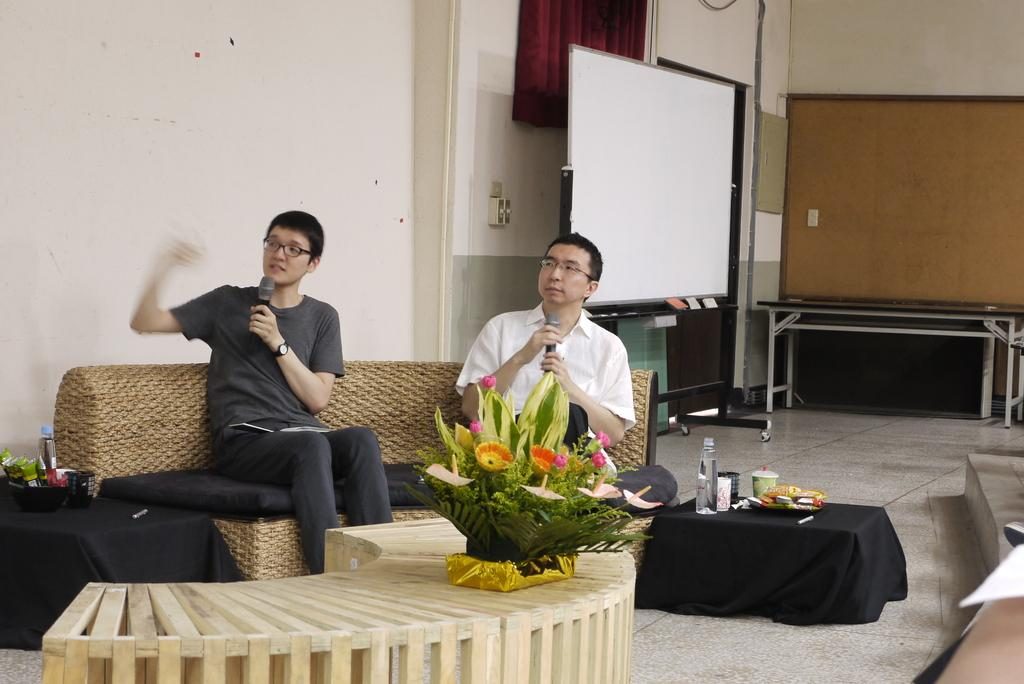How many people are present in the image? There are two men seated in the image. What are the men doing in the image? The men are speaking with the help of a microphone. What objects can be seen on the table in the image? There is a flower vase and a water bottle on the table. What is the purpose of the whiteboard in the image? The whiteboard might be used for writing or displaying information during the conversation. What type of stitch is being used to sew the relation between the two men in the image? There is no stitching or relation being sewn in the image; it features two men speaking with a microphone. 